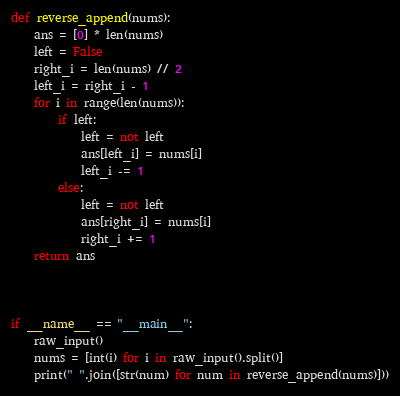Convert code to text. <code><loc_0><loc_0><loc_500><loc_500><_Python_>def reverse_append(nums):
    ans = [0] * len(nums)
    left = False
    right_i = len(nums) // 2
    left_i = right_i - 1
    for i in range(len(nums)):
        if left:
            left = not left
            ans[left_i] = nums[i]
            left_i -= 1
        else:
            left = not left
            ans[right_i] = nums[i]
            right_i += 1
    return ans



if __name__ == "__main__":
    raw_input()
    nums = [int(i) for i in raw_input().split()]
    print(" ".join([str(num) for num in reverse_append(nums)]))</code> 